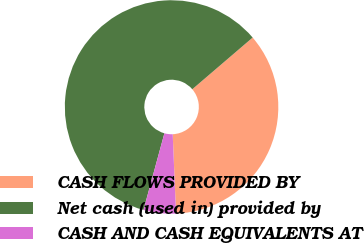Convert chart to OTSL. <chart><loc_0><loc_0><loc_500><loc_500><pie_chart><fcel>CASH FLOWS PROVIDED BY<fcel>Net cash (used in) provided by<fcel>CASH AND CASH EQUIVALENTS AT<nl><fcel>35.61%<fcel>59.5%<fcel>4.9%<nl></chart> 